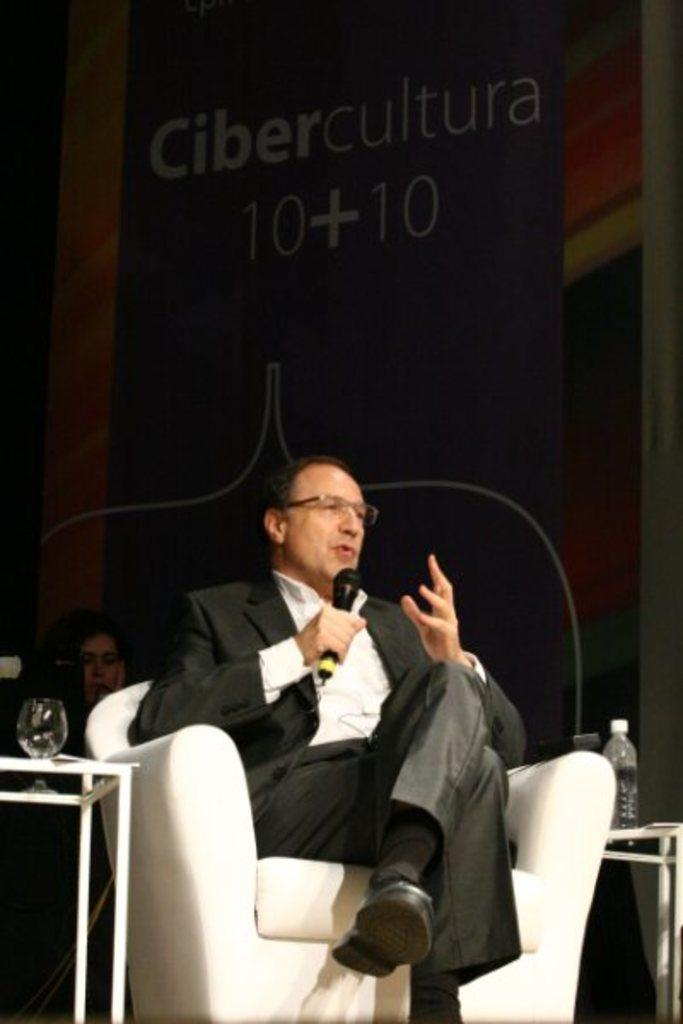What is the man in the image doing? The man is sitting on a chair in the image. What is the man holding in his hand? The man is holding a microphone in his hand. What is the man wearing? The man is wearing a black suit. How many tables are visible in the image? There are two tables in the image. What objects can be seen on the tables? There is a bottle and a glass on one of the tables. What type of guitar is the man playing in the image? There is no guitar present in the image; the man is holding a microphone. What color is the collar of the man's shirt in the image? The man is wearing a suit, not a shirt, and there is no mention of a collar in the provided facts. 